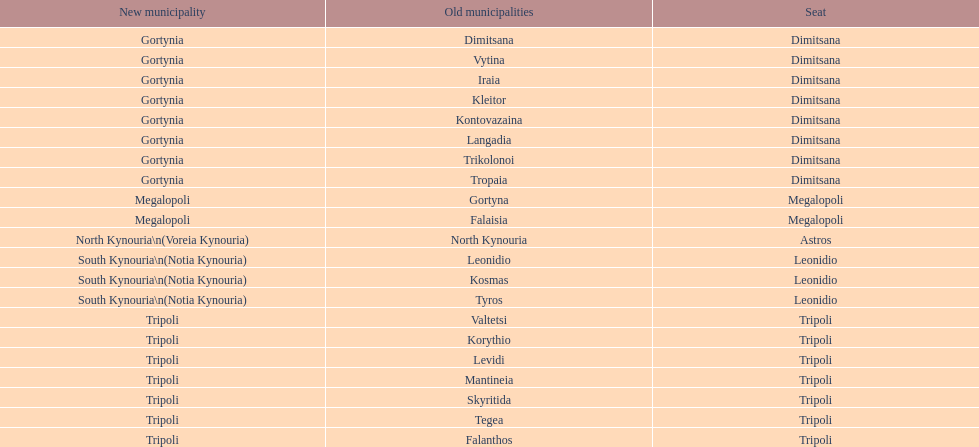What is the novel municipality of tyros? South Kynouria. 